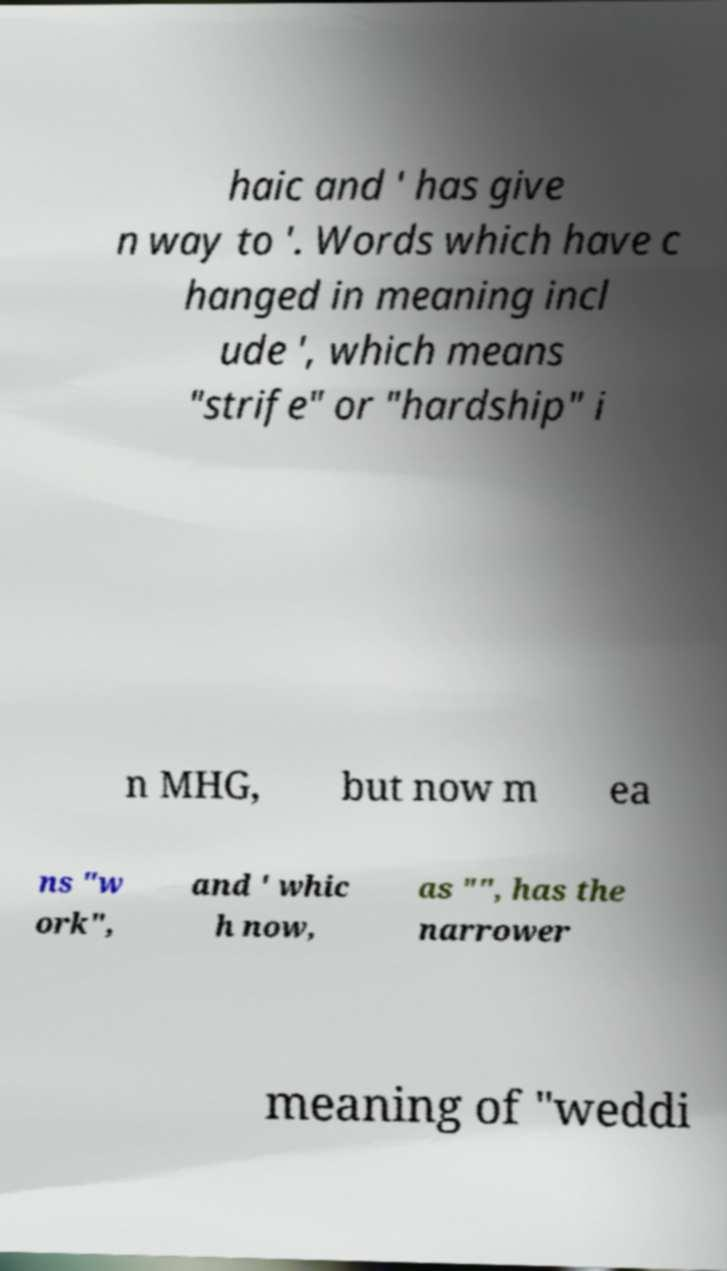Could you extract and type out the text from this image? haic and ' has give n way to '. Words which have c hanged in meaning incl ude ', which means "strife" or "hardship" i n MHG, but now m ea ns "w ork", and ' whic h now, as "", has the narrower meaning of "weddi 